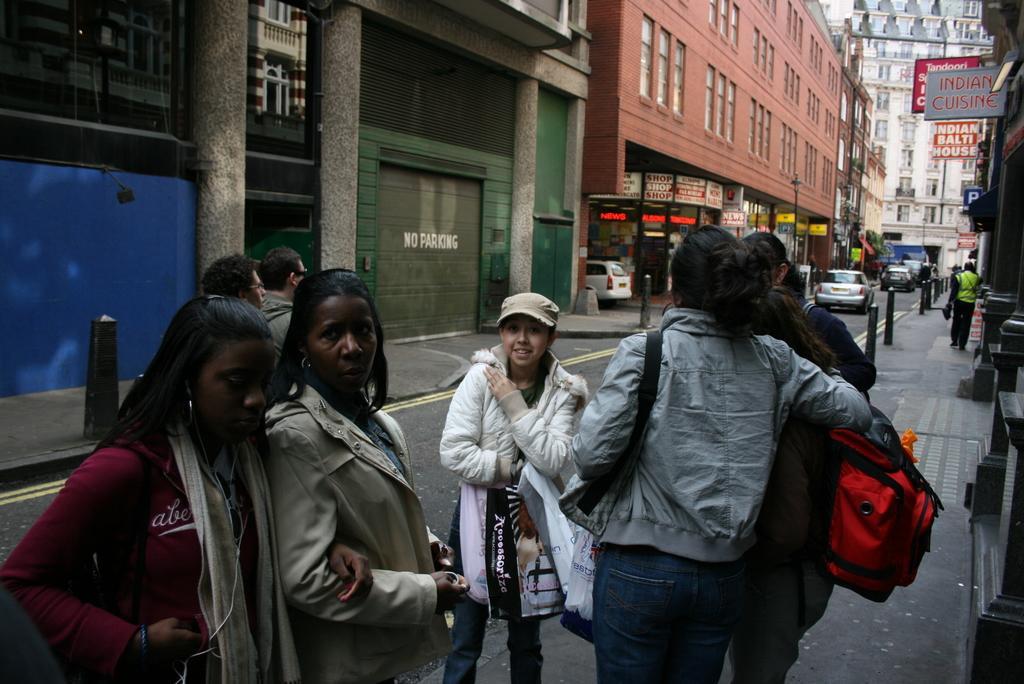How would you summarize this image in a sentence or two? In the center of the image there are people standing on the road. In the background of the image there are buildings, stores. There are cars on the road. To the right side of the image there are boards with some text. 